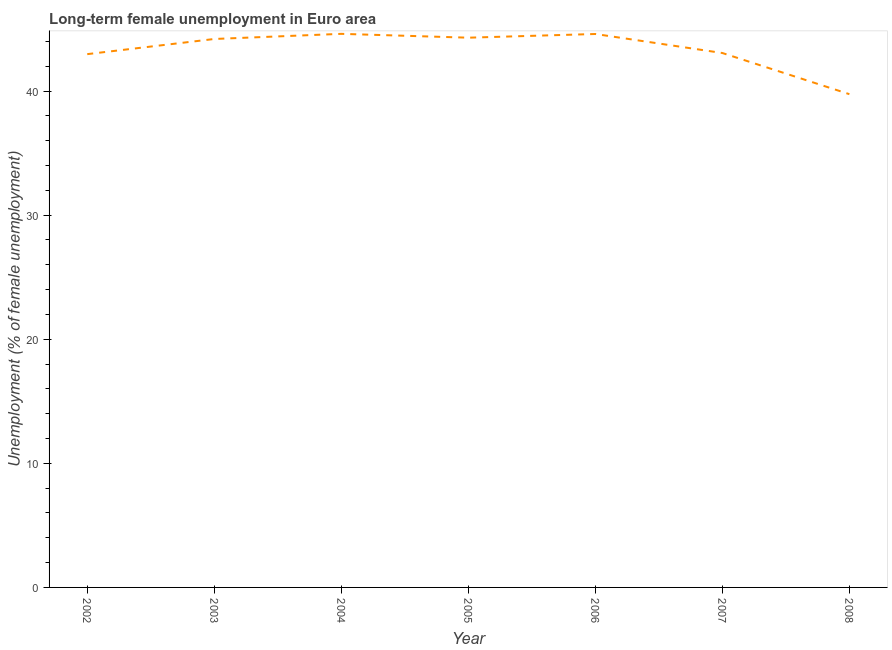What is the long-term female unemployment in 2008?
Make the answer very short. 39.75. Across all years, what is the maximum long-term female unemployment?
Give a very brief answer. 44.61. Across all years, what is the minimum long-term female unemployment?
Make the answer very short. 39.75. What is the sum of the long-term female unemployment?
Keep it short and to the point. 303.5. What is the difference between the long-term female unemployment in 2003 and 2007?
Keep it short and to the point. 1.13. What is the average long-term female unemployment per year?
Your response must be concise. 43.36. What is the median long-term female unemployment?
Provide a succinct answer. 44.2. In how many years, is the long-term female unemployment greater than 28 %?
Give a very brief answer. 7. What is the ratio of the long-term female unemployment in 2002 to that in 2005?
Offer a terse response. 0.97. Is the difference between the long-term female unemployment in 2004 and 2006 greater than the difference between any two years?
Make the answer very short. No. What is the difference between the highest and the second highest long-term female unemployment?
Make the answer very short. 0.01. Is the sum of the long-term female unemployment in 2004 and 2006 greater than the maximum long-term female unemployment across all years?
Provide a succinct answer. Yes. What is the difference between the highest and the lowest long-term female unemployment?
Your answer should be compact. 4.86. Are the values on the major ticks of Y-axis written in scientific E-notation?
Your answer should be compact. No. Does the graph contain any zero values?
Offer a very short reply. No. Does the graph contain grids?
Provide a succinct answer. No. What is the title of the graph?
Offer a very short reply. Long-term female unemployment in Euro area. What is the label or title of the Y-axis?
Provide a short and direct response. Unemployment (% of female unemployment). What is the Unemployment (% of female unemployment) of 2002?
Give a very brief answer. 42.98. What is the Unemployment (% of female unemployment) of 2003?
Provide a short and direct response. 44.2. What is the Unemployment (% of female unemployment) of 2004?
Your answer should be compact. 44.61. What is the Unemployment (% of female unemployment) of 2005?
Give a very brief answer. 44.3. What is the Unemployment (% of female unemployment) of 2006?
Provide a succinct answer. 44.6. What is the Unemployment (% of female unemployment) of 2007?
Offer a very short reply. 43.07. What is the Unemployment (% of female unemployment) in 2008?
Provide a short and direct response. 39.75. What is the difference between the Unemployment (% of female unemployment) in 2002 and 2003?
Make the answer very short. -1.22. What is the difference between the Unemployment (% of female unemployment) in 2002 and 2004?
Offer a terse response. -1.64. What is the difference between the Unemployment (% of female unemployment) in 2002 and 2005?
Your response must be concise. -1.33. What is the difference between the Unemployment (% of female unemployment) in 2002 and 2006?
Keep it short and to the point. -1.62. What is the difference between the Unemployment (% of female unemployment) in 2002 and 2007?
Provide a short and direct response. -0.09. What is the difference between the Unemployment (% of female unemployment) in 2002 and 2008?
Offer a very short reply. 3.23. What is the difference between the Unemployment (% of female unemployment) in 2003 and 2004?
Your answer should be compact. -0.41. What is the difference between the Unemployment (% of female unemployment) in 2003 and 2005?
Give a very brief answer. -0.1. What is the difference between the Unemployment (% of female unemployment) in 2003 and 2006?
Ensure brevity in your answer.  -0.4. What is the difference between the Unemployment (% of female unemployment) in 2003 and 2007?
Give a very brief answer. 1.13. What is the difference between the Unemployment (% of female unemployment) in 2003 and 2008?
Ensure brevity in your answer.  4.45. What is the difference between the Unemployment (% of female unemployment) in 2004 and 2005?
Offer a very short reply. 0.31. What is the difference between the Unemployment (% of female unemployment) in 2004 and 2006?
Ensure brevity in your answer.  0.01. What is the difference between the Unemployment (% of female unemployment) in 2004 and 2007?
Your answer should be very brief. 1.54. What is the difference between the Unemployment (% of female unemployment) in 2004 and 2008?
Keep it short and to the point. 4.86. What is the difference between the Unemployment (% of female unemployment) in 2005 and 2006?
Provide a short and direct response. -0.3. What is the difference between the Unemployment (% of female unemployment) in 2005 and 2007?
Your response must be concise. 1.24. What is the difference between the Unemployment (% of female unemployment) in 2005 and 2008?
Ensure brevity in your answer.  4.55. What is the difference between the Unemployment (% of female unemployment) in 2006 and 2007?
Make the answer very short. 1.53. What is the difference between the Unemployment (% of female unemployment) in 2006 and 2008?
Your response must be concise. 4.85. What is the difference between the Unemployment (% of female unemployment) in 2007 and 2008?
Offer a terse response. 3.32. What is the ratio of the Unemployment (% of female unemployment) in 2002 to that in 2003?
Your answer should be very brief. 0.97. What is the ratio of the Unemployment (% of female unemployment) in 2002 to that in 2004?
Offer a very short reply. 0.96. What is the ratio of the Unemployment (% of female unemployment) in 2002 to that in 2005?
Your response must be concise. 0.97. What is the ratio of the Unemployment (% of female unemployment) in 2002 to that in 2007?
Provide a short and direct response. 1. What is the ratio of the Unemployment (% of female unemployment) in 2002 to that in 2008?
Offer a terse response. 1.08. What is the ratio of the Unemployment (% of female unemployment) in 2003 to that in 2004?
Provide a short and direct response. 0.99. What is the ratio of the Unemployment (% of female unemployment) in 2003 to that in 2006?
Your response must be concise. 0.99. What is the ratio of the Unemployment (% of female unemployment) in 2003 to that in 2007?
Your answer should be very brief. 1.03. What is the ratio of the Unemployment (% of female unemployment) in 2003 to that in 2008?
Your response must be concise. 1.11. What is the ratio of the Unemployment (% of female unemployment) in 2004 to that in 2005?
Give a very brief answer. 1.01. What is the ratio of the Unemployment (% of female unemployment) in 2004 to that in 2007?
Provide a succinct answer. 1.04. What is the ratio of the Unemployment (% of female unemployment) in 2004 to that in 2008?
Ensure brevity in your answer.  1.12. What is the ratio of the Unemployment (% of female unemployment) in 2005 to that in 2006?
Give a very brief answer. 0.99. What is the ratio of the Unemployment (% of female unemployment) in 2005 to that in 2008?
Your response must be concise. 1.11. What is the ratio of the Unemployment (% of female unemployment) in 2006 to that in 2007?
Make the answer very short. 1.04. What is the ratio of the Unemployment (% of female unemployment) in 2006 to that in 2008?
Provide a succinct answer. 1.12. What is the ratio of the Unemployment (% of female unemployment) in 2007 to that in 2008?
Give a very brief answer. 1.08. 